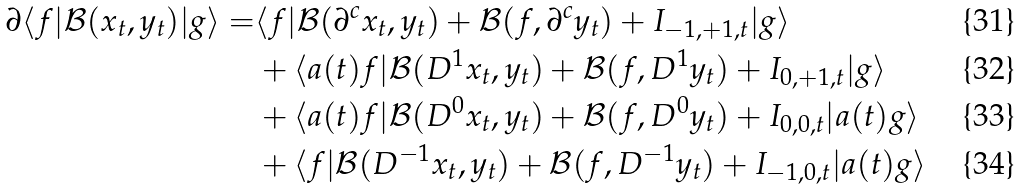<formula> <loc_0><loc_0><loc_500><loc_500>\partial \langle f | \mathcal { B } ( x _ { t } , y _ { t } ) | g \rangle = & \langle f | \mathcal { B } ( \partial ^ { c } x _ { t } , y _ { t } ) + \mathcal { B } ( f , \partial ^ { c } y _ { t } ) + I _ { - 1 , + 1 , t } | g \rangle \\ & + \langle a ( t ) f | \mathcal { B } ( D ^ { 1 } x _ { t } , y _ { t } ) + \mathcal { B } ( f , D ^ { 1 } y _ { t } ) + I _ { 0 , + 1 , t } | g \rangle \\ & + \langle a ( t ) f | \mathcal { B } ( D ^ { 0 } x _ { t } , y _ { t } ) + \mathcal { B } ( f , D ^ { 0 } y _ { t } ) + I _ { 0 , 0 , t } | a ( t ) g \rangle \\ & + \langle f | \mathcal { B } ( D ^ { - 1 } x _ { t } , y _ { t } ) + \mathcal { B } ( f , D ^ { - 1 } y _ { t } ) + I _ { - 1 , 0 , t } | a ( t ) g \rangle</formula> 